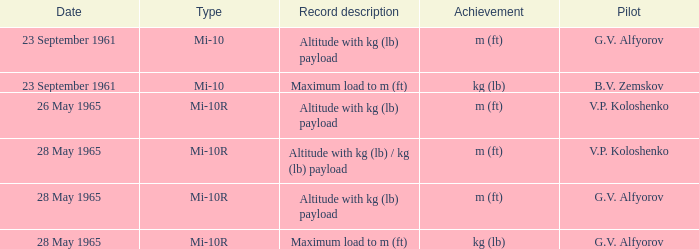Type of mi-10r, and a Record description of altitude with kg (lb) payload, and a Pilot of g.v. alfyorov is what date? 28 May 1965. Would you mind parsing the complete table? {'header': ['Date', 'Type', 'Record description', 'Achievement', 'Pilot'], 'rows': [['23 September 1961', 'Mi-10', 'Altitude with kg (lb) payload', 'm (ft)', 'G.V. Alfyorov'], ['23 September 1961', 'Mi-10', 'Maximum load to m (ft)', 'kg (lb)', 'B.V. Zemskov'], ['26 May 1965', 'Mi-10R', 'Altitude with kg (lb) payload', 'm (ft)', 'V.P. Koloshenko'], ['28 May 1965', 'Mi-10R', 'Altitude with kg (lb) / kg (lb) payload', 'm (ft)', 'V.P. Koloshenko'], ['28 May 1965', 'Mi-10R', 'Altitude with kg (lb) payload', 'm (ft)', 'G.V. Alfyorov'], ['28 May 1965', 'Mi-10R', 'Maximum load to m (ft)', 'kg (lb)', 'G.V. Alfyorov']]} 